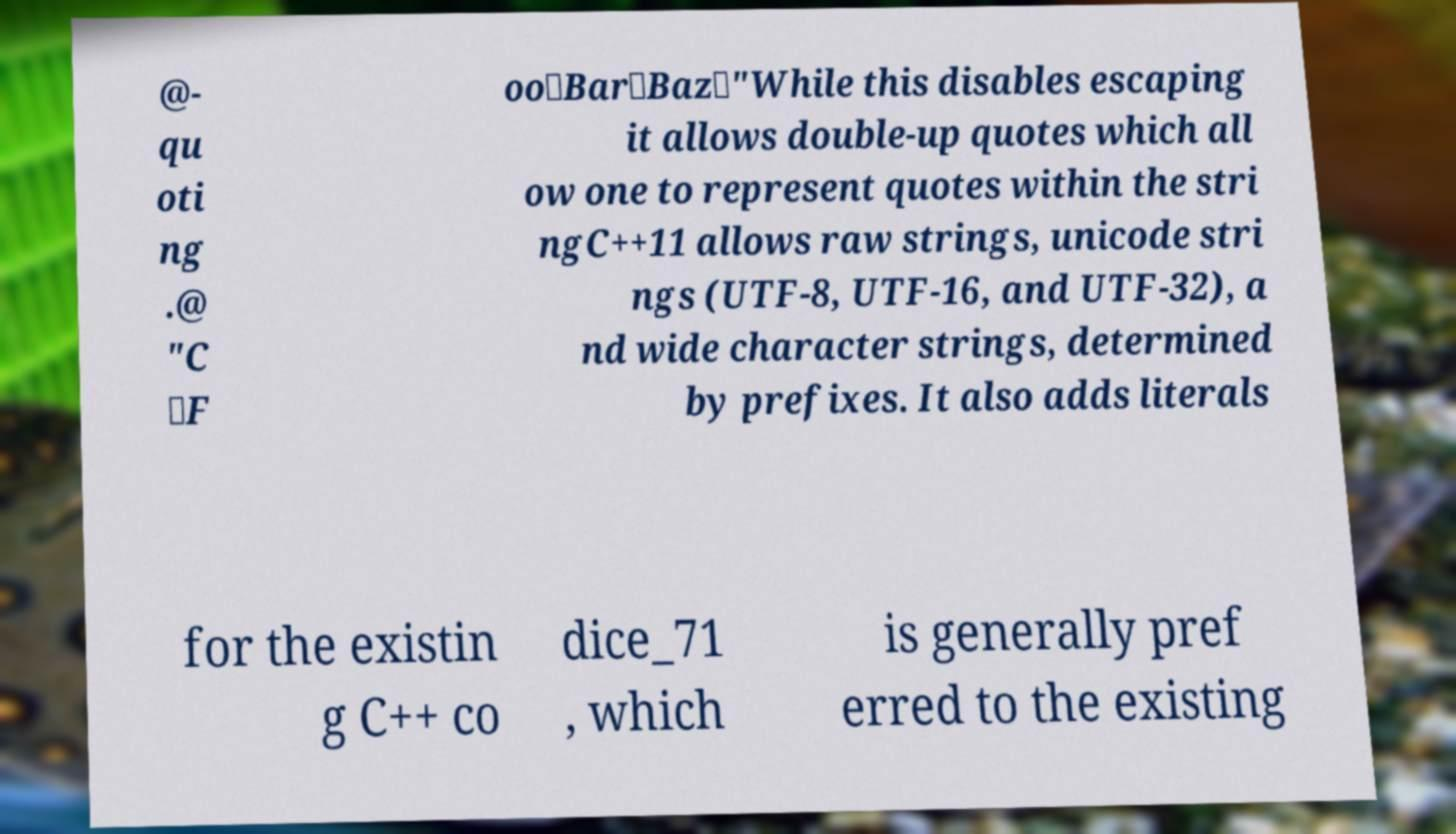There's text embedded in this image that I need extracted. Can you transcribe it verbatim? @- qu oti ng .@ "C \F oo\Bar\Baz\"While this disables escaping it allows double-up quotes which all ow one to represent quotes within the stri ngC++11 allows raw strings, unicode stri ngs (UTF-8, UTF-16, and UTF-32), a nd wide character strings, determined by prefixes. It also adds literals for the existin g C++ co dice_71 , which is generally pref erred to the existing 